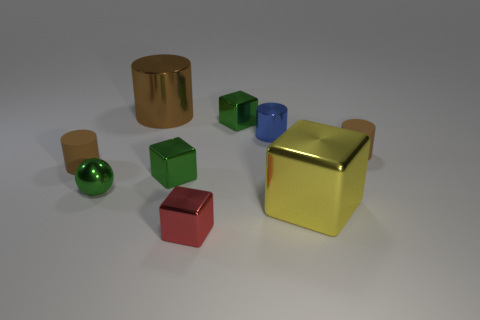Subtract all brown cylinders. How many were subtracted if there are1brown cylinders left? 2 Subtract all gray blocks. How many brown cylinders are left? 3 Subtract 1 cubes. How many cubes are left? 3 Add 1 large purple rubber cylinders. How many objects exist? 10 Subtract all cubes. How many objects are left? 5 Add 2 yellow cubes. How many yellow cubes are left? 3 Add 1 large yellow things. How many large yellow things exist? 2 Subtract 0 cyan balls. How many objects are left? 9 Subtract all large green rubber things. Subtract all tiny red cubes. How many objects are left? 8 